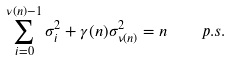Convert formula to latex. <formula><loc_0><loc_0><loc_500><loc_500>\sum _ { i = 0 } ^ { \nu ( n ) - 1 } \sigma _ { i } ^ { 2 } + \gamma ( n ) \sigma _ { \nu ( n ) } ^ { 2 } = n \quad \, p . s .</formula> 